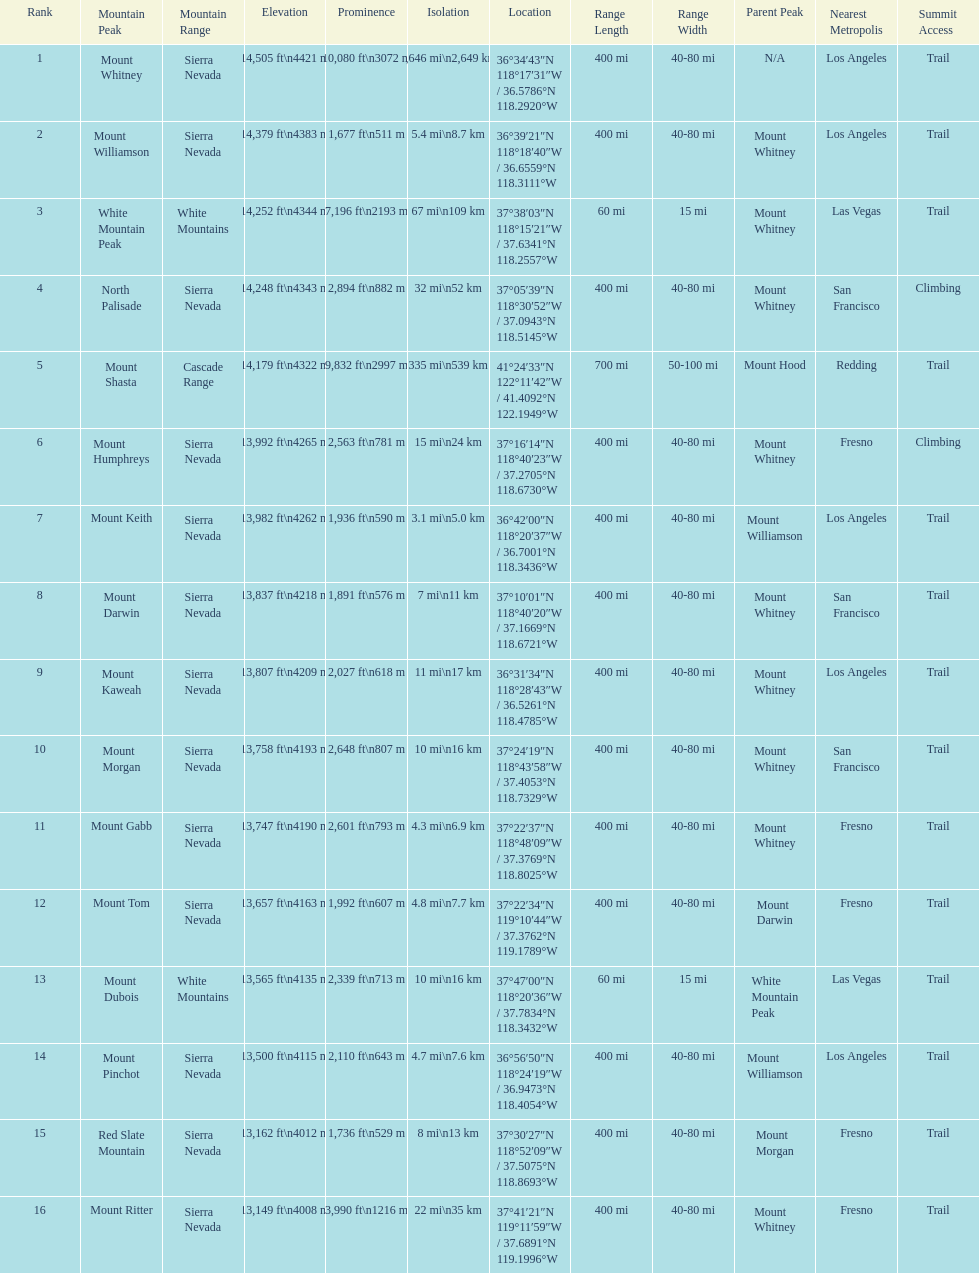Which mountain peak is the only mountain peak in the cascade range? Mount Shasta. 